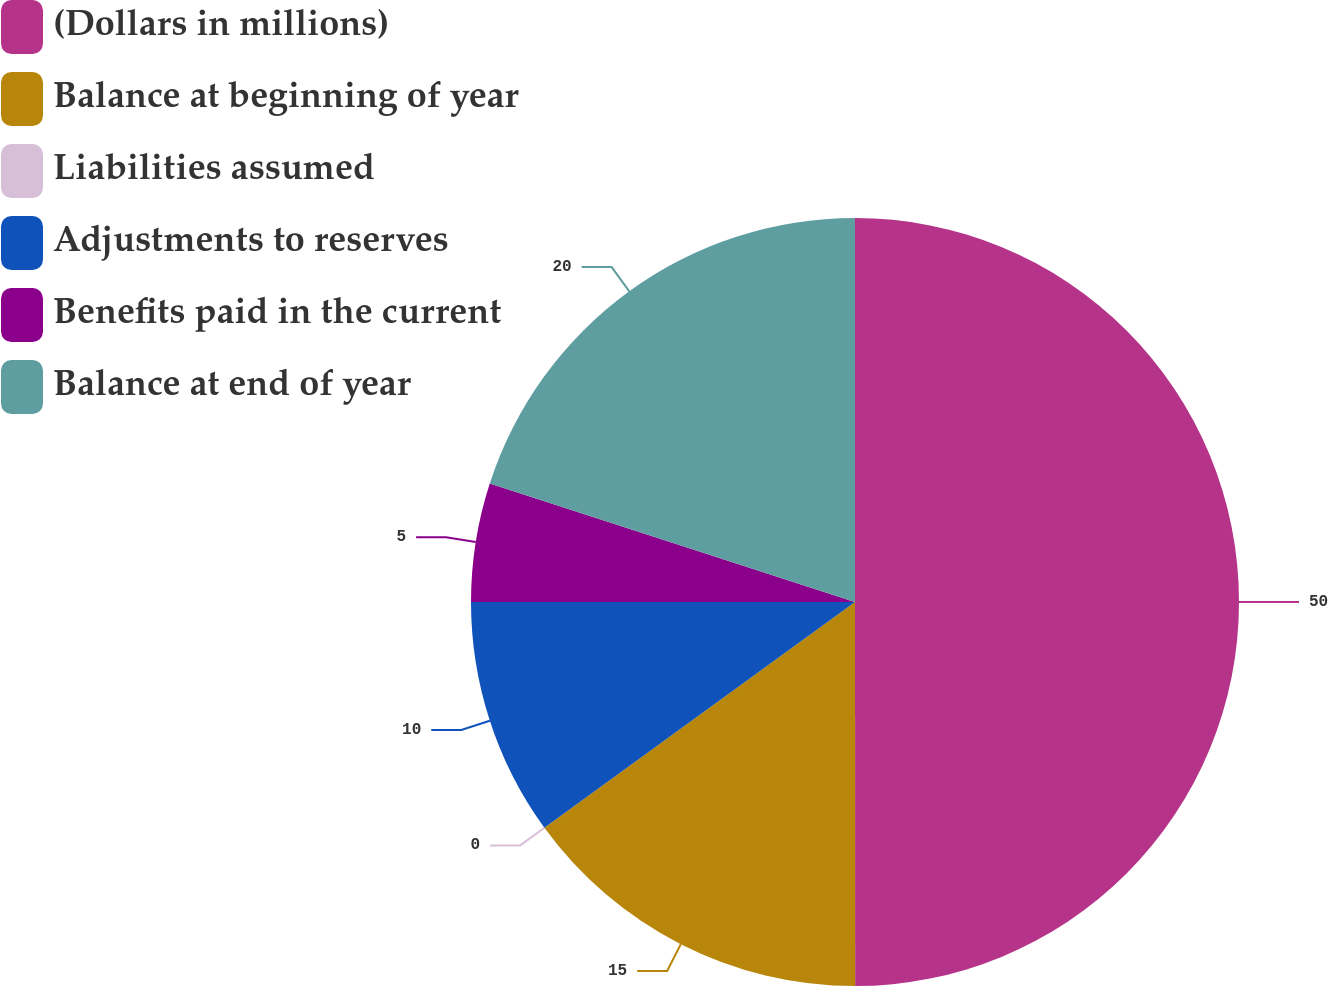<chart> <loc_0><loc_0><loc_500><loc_500><pie_chart><fcel>(Dollars in millions)<fcel>Balance at beginning of year<fcel>Liabilities assumed<fcel>Adjustments to reserves<fcel>Benefits paid in the current<fcel>Balance at end of year<nl><fcel>49.99%<fcel>15.0%<fcel>0.0%<fcel>10.0%<fcel>5.0%<fcel>20.0%<nl></chart> 